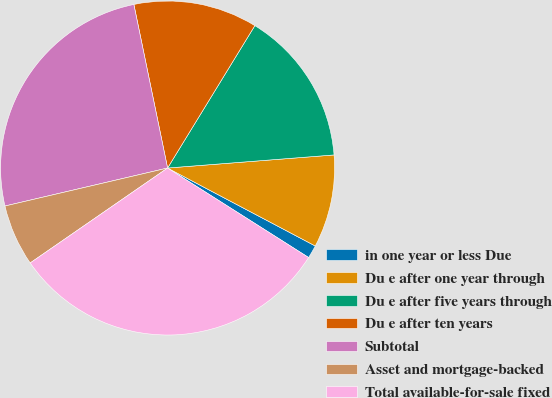Convert chart to OTSL. <chart><loc_0><loc_0><loc_500><loc_500><pie_chart><fcel>in one year or less Due<fcel>Du e after one year through<fcel>Du e after five years through<fcel>Du e after ten years<fcel>Subtotal<fcel>Asset and mortgage-backed<fcel>Total available-for-sale fixed<nl><fcel>1.27%<fcel>8.98%<fcel>15.0%<fcel>11.99%<fcel>25.42%<fcel>5.97%<fcel>31.38%<nl></chart> 